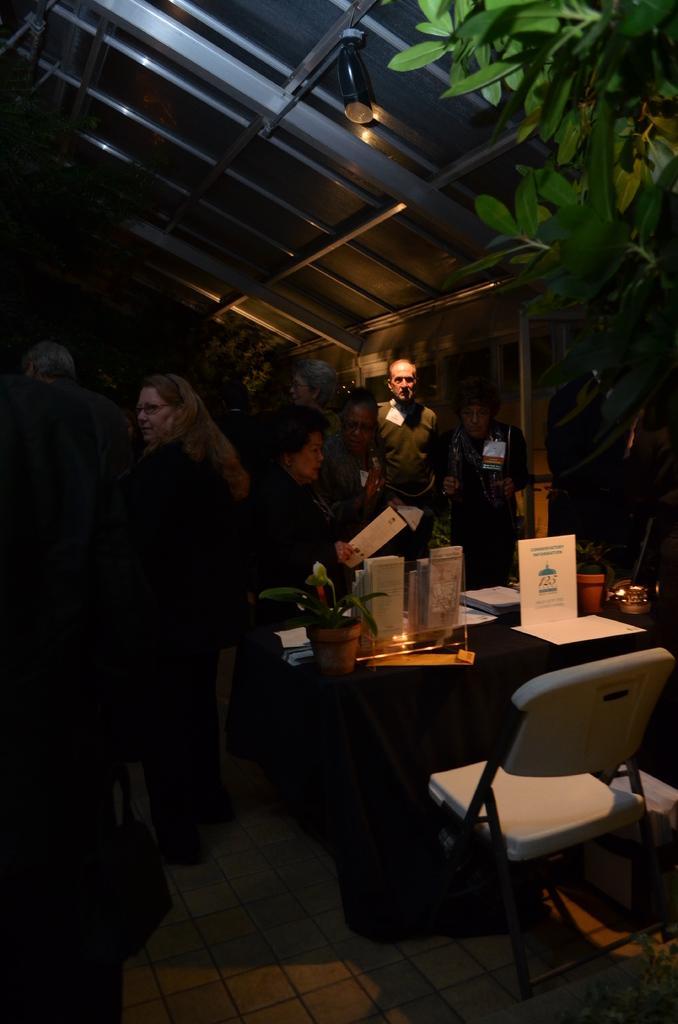In one or two sentences, can you explain what this image depicts? The image is somewhat dark. On the right side there is a tree and few people here and there and in the front there is a table and a chair. On table there are posters and bowls. 